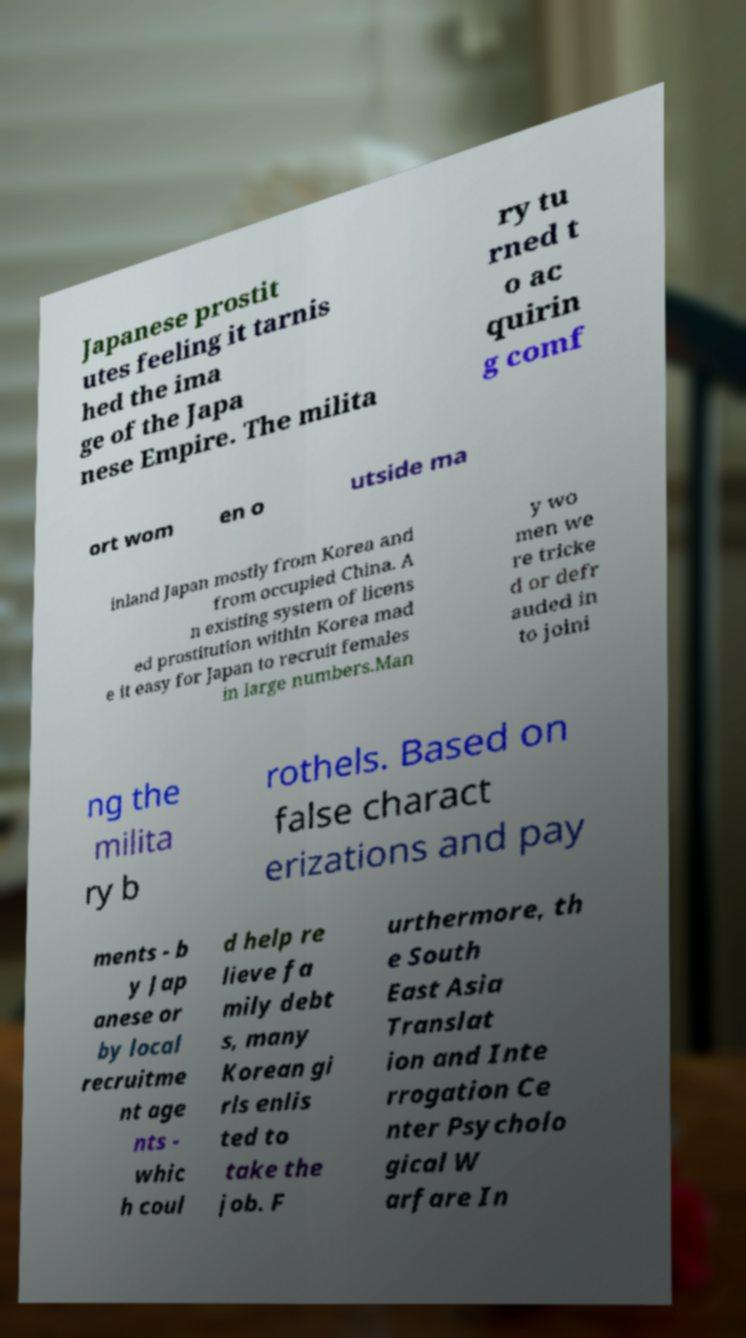Could you extract and type out the text from this image? Japanese prostit utes feeling it tarnis hed the ima ge of the Japa nese Empire. The milita ry tu rned t o ac quirin g comf ort wom en o utside ma inland Japan mostly from Korea and from occupied China. A n existing system of licens ed prostitution within Korea mad e it easy for Japan to recruit females in large numbers.Man y wo men we re tricke d or defr auded in to joini ng the milita ry b rothels. Based on false charact erizations and pay ments - b y Jap anese or by local recruitme nt age nts - whic h coul d help re lieve fa mily debt s, many Korean gi rls enlis ted to take the job. F urthermore, th e South East Asia Translat ion and Inte rrogation Ce nter Psycholo gical W arfare In 